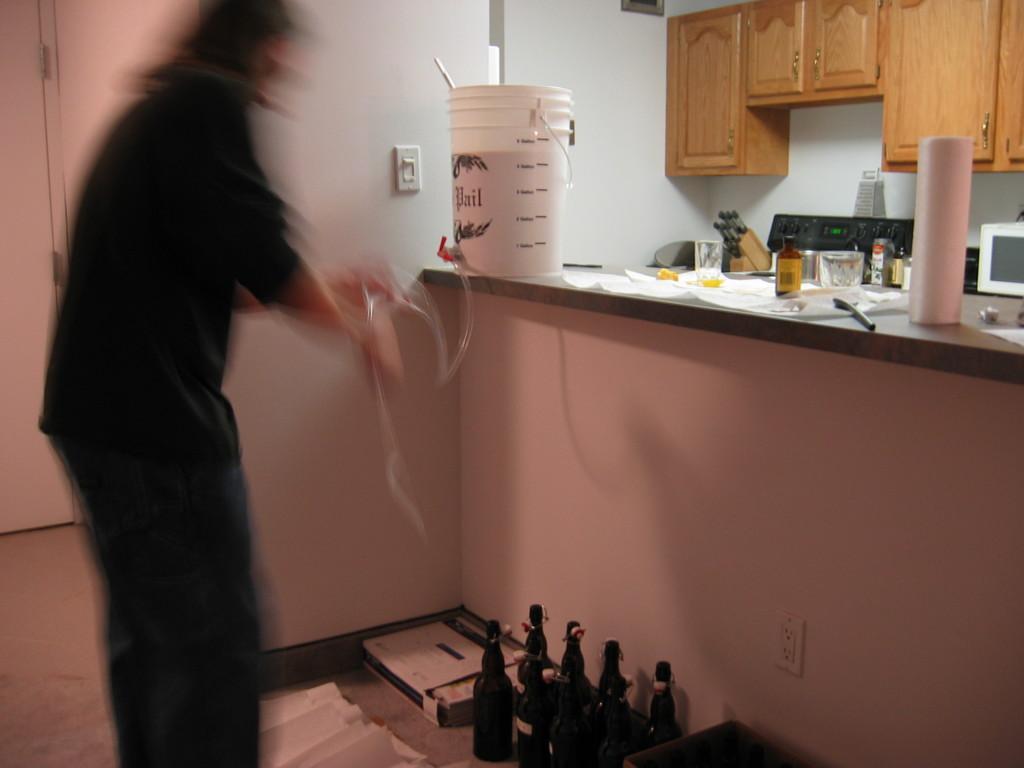Describe this image in one or two sentences. On the left we can see a person standing on the floor by holding a pipe in his hands and there are wine bottles and a box on the floor. On the platform we can see a bucket,gas stove,bottles,an electronic device and other objects. We can see a door,an object on the wall and cupboards. 